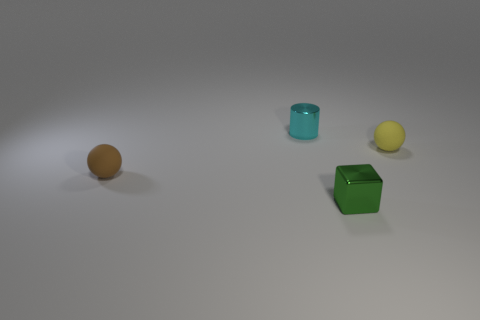There is a ball to the left of the rubber sphere that is behind the brown object; what is it made of? The ball to the left of the rubber sphere, which is behind the brown square object, appears to be made of a matte material that might be plastic or another similar synthetic substance; it has a slightly reflective surface and a texture consistent with that of a standard practice sports ball. 